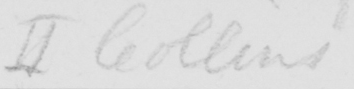What text is written in this handwritten line? II Collins 